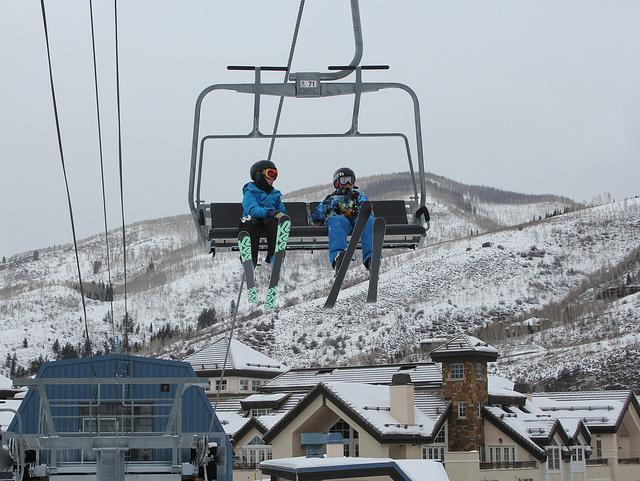Which comparative elevation do the seated people wish for? higher 